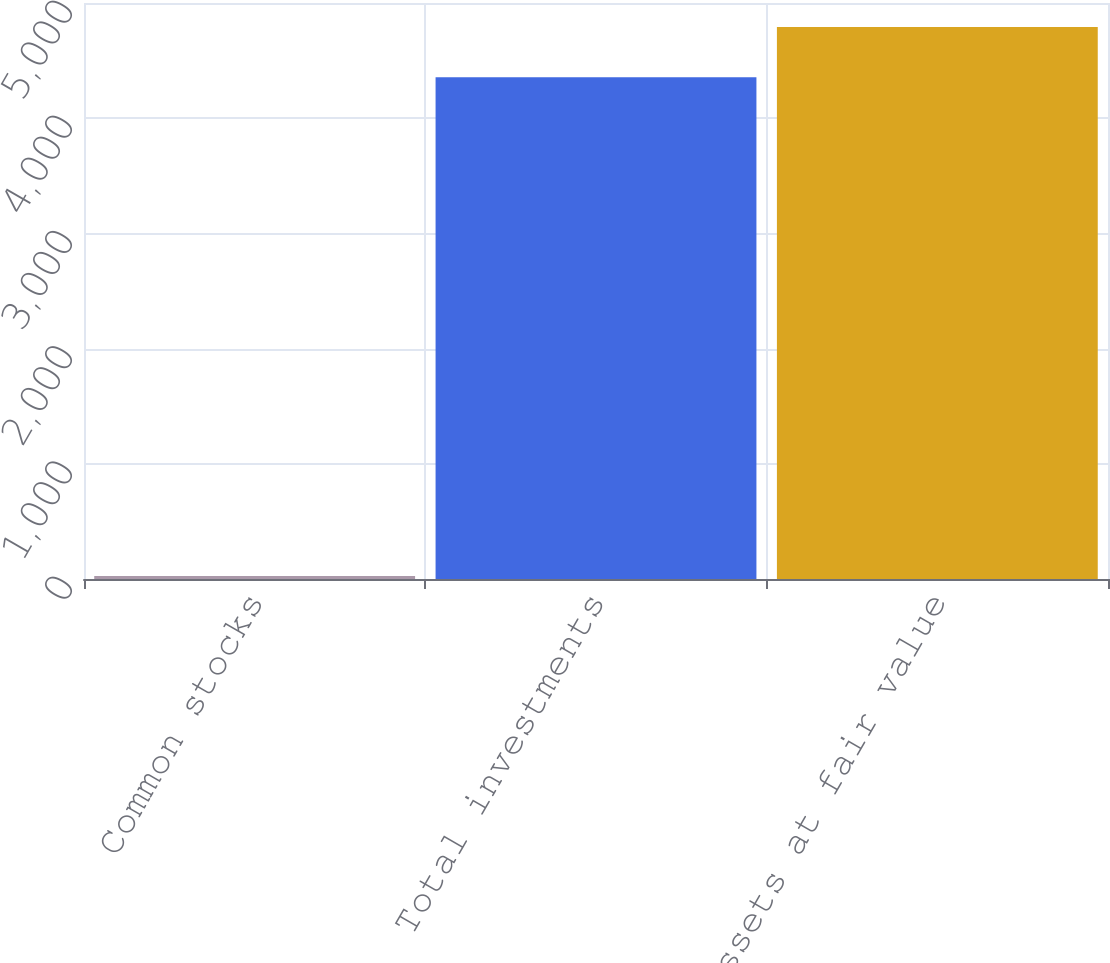Convert chart to OTSL. <chart><loc_0><loc_0><loc_500><loc_500><bar_chart><fcel>Common stocks<fcel>Total investments<fcel>Total assets at fair value<nl><fcel>25<fcel>4355<fcel>4792.1<nl></chart> 